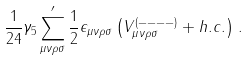Convert formula to latex. <formula><loc_0><loc_0><loc_500><loc_500>\frac { 1 } { 2 4 } \gamma _ { 5 } \sum _ { \mu \nu \rho \sigma } ^ { \prime } \frac { 1 } { 2 } \epsilon _ { \mu \nu \rho \sigma } \left ( V _ { \mu \nu \rho \sigma } ^ { ( - - - - ) } + h . c . \right ) \, .</formula> 